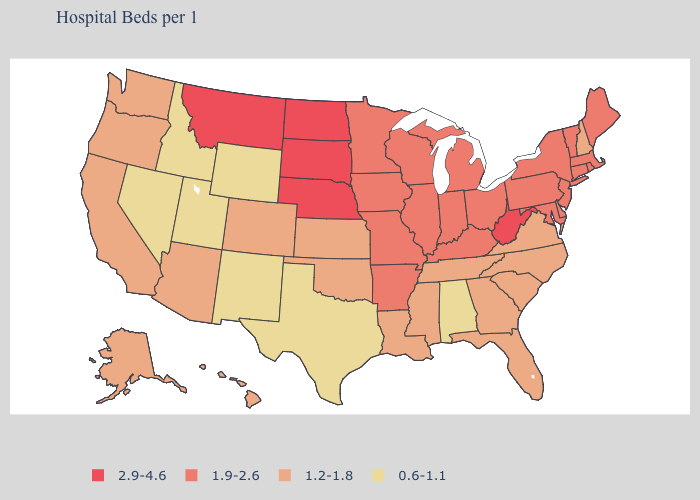Which states have the lowest value in the Northeast?
Give a very brief answer. New Hampshire. Name the states that have a value in the range 1.2-1.8?
Quick response, please. Alaska, Arizona, California, Colorado, Florida, Georgia, Hawaii, Kansas, Louisiana, Mississippi, New Hampshire, North Carolina, Oklahoma, Oregon, South Carolina, Tennessee, Virginia, Washington. What is the value of Arizona?
Keep it brief. 1.2-1.8. What is the highest value in the USA?
Write a very short answer. 2.9-4.6. Name the states that have a value in the range 2.9-4.6?
Keep it brief. Montana, Nebraska, North Dakota, South Dakota, West Virginia. Name the states that have a value in the range 1.2-1.8?
Write a very short answer. Alaska, Arizona, California, Colorado, Florida, Georgia, Hawaii, Kansas, Louisiana, Mississippi, New Hampshire, North Carolina, Oklahoma, Oregon, South Carolina, Tennessee, Virginia, Washington. Does the first symbol in the legend represent the smallest category?
Give a very brief answer. No. Which states have the highest value in the USA?
Write a very short answer. Montana, Nebraska, North Dakota, South Dakota, West Virginia. Name the states that have a value in the range 0.6-1.1?
Quick response, please. Alabama, Idaho, Nevada, New Mexico, Texas, Utah, Wyoming. What is the value of New Hampshire?
Write a very short answer. 1.2-1.8. How many symbols are there in the legend?
Short answer required. 4. What is the value of Florida?
Answer briefly. 1.2-1.8. What is the value of Colorado?
Keep it brief. 1.2-1.8. Does Nebraska have the highest value in the MidWest?
Be succinct. Yes. What is the highest value in the USA?
Quick response, please. 2.9-4.6. 